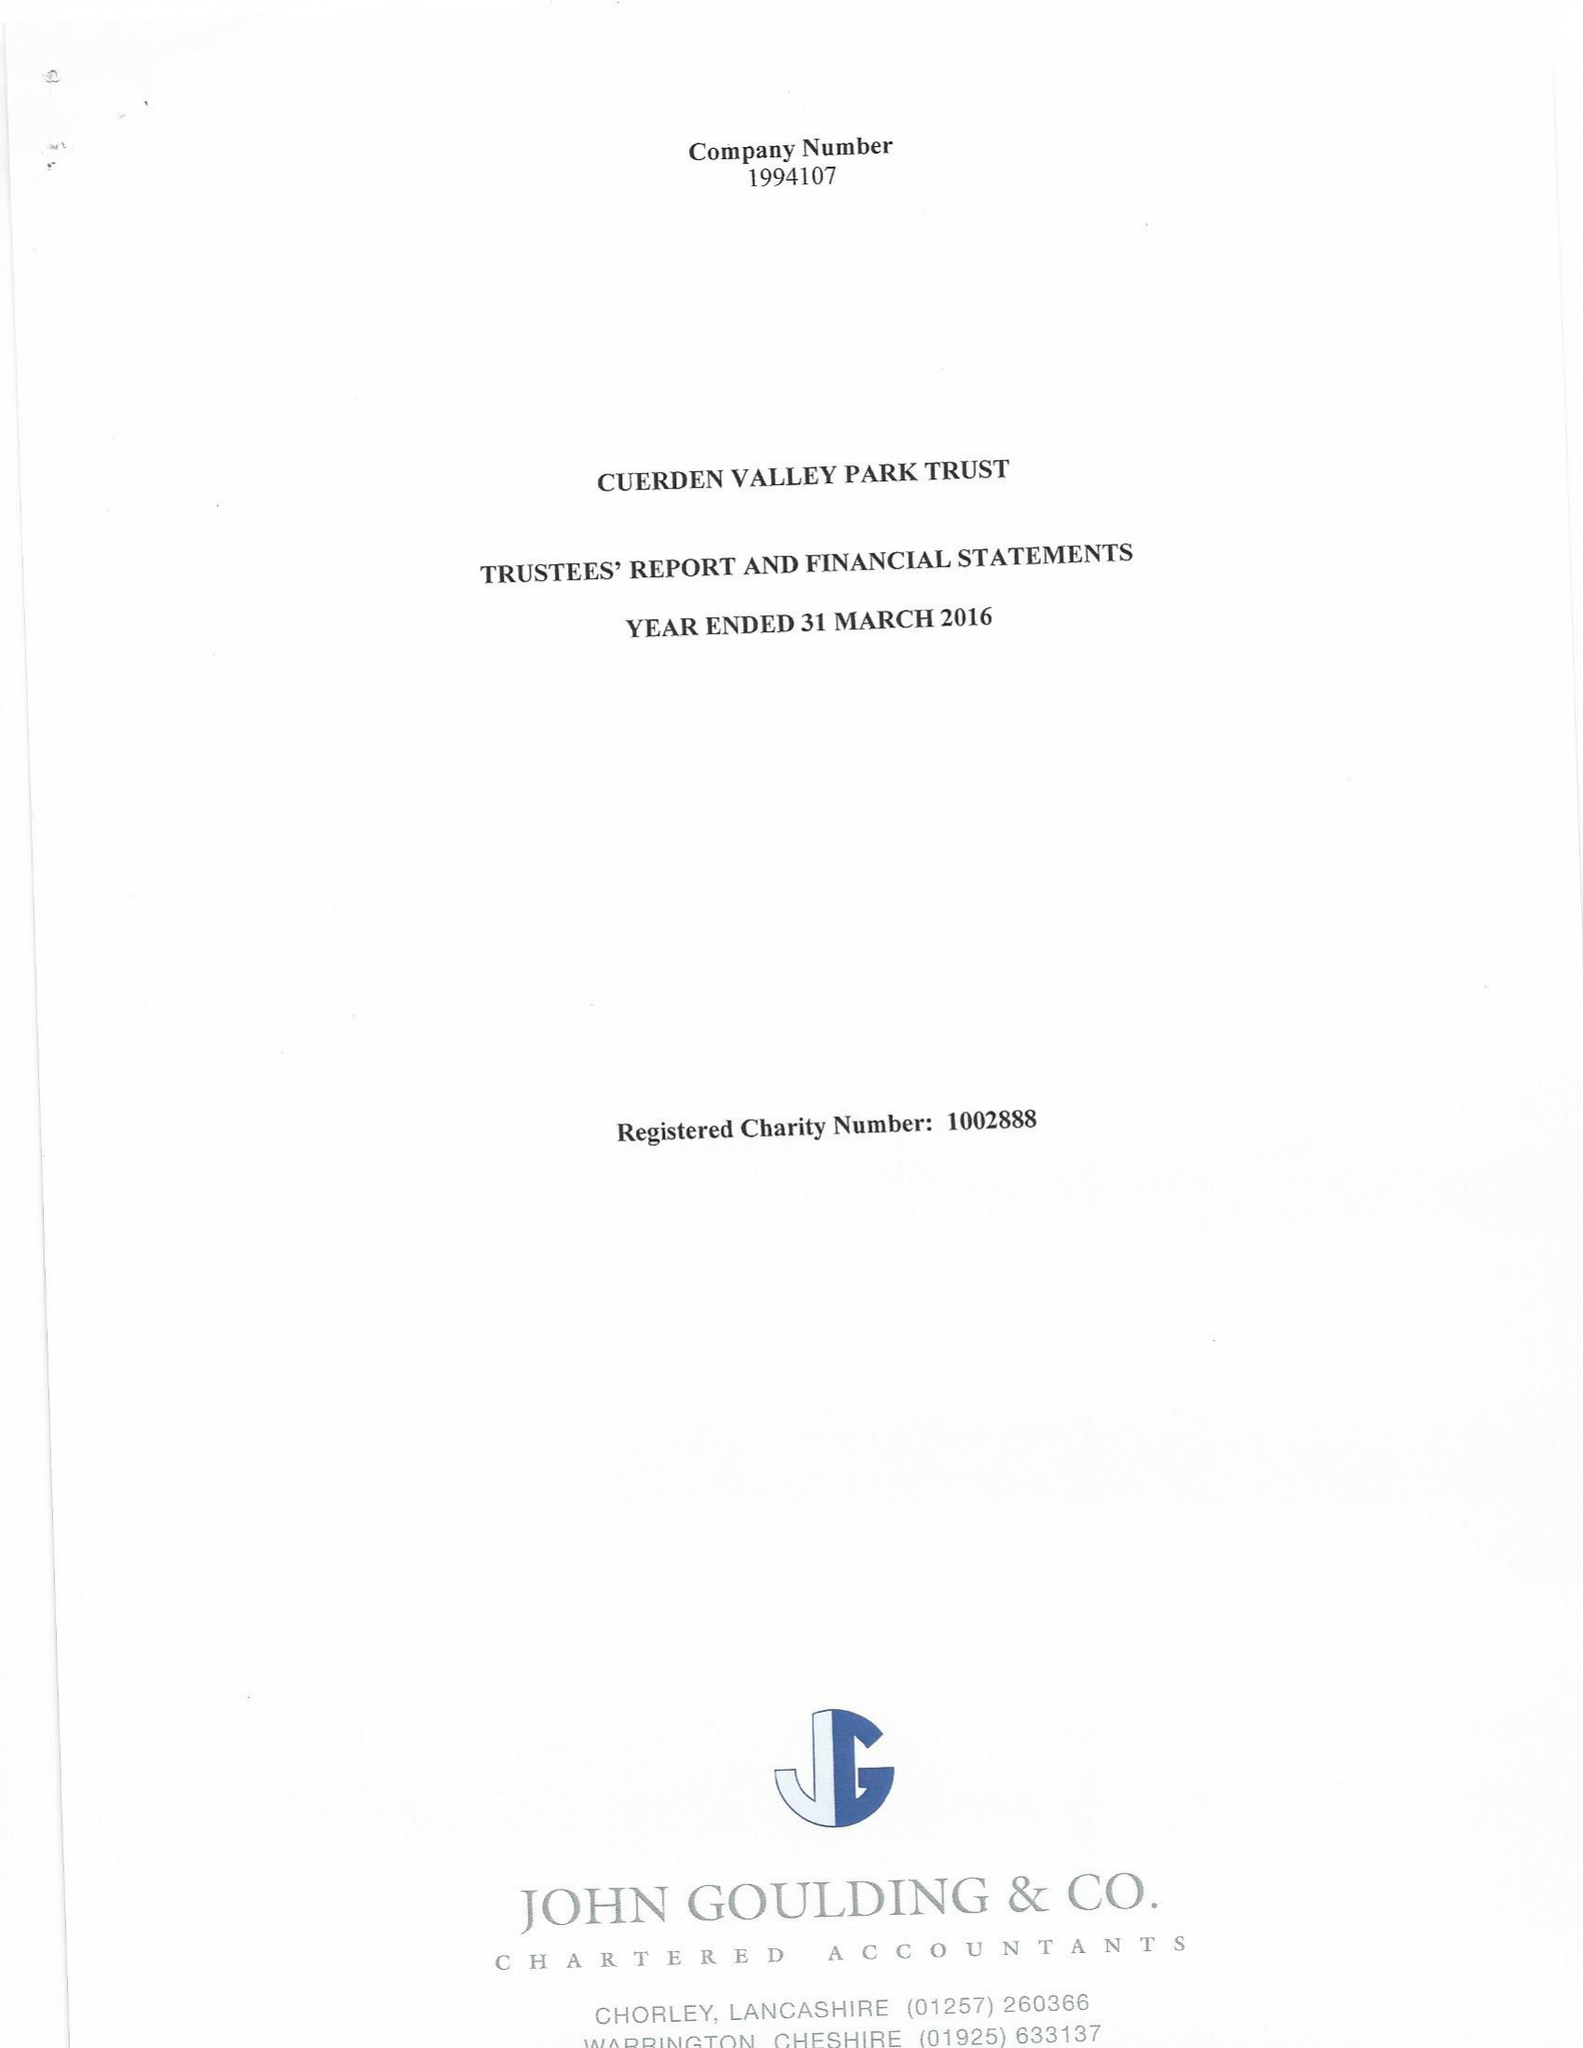What is the value for the address__postcode?
Answer the question using a single word or phrase. PR5 6BY 